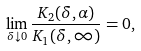Convert formula to latex. <formula><loc_0><loc_0><loc_500><loc_500>\lim _ { \delta \downarrow 0 } \frac { K _ { 2 } ( \delta , \alpha ) } { K _ { 1 } ( \delta , \infty ) } = 0 ,</formula> 